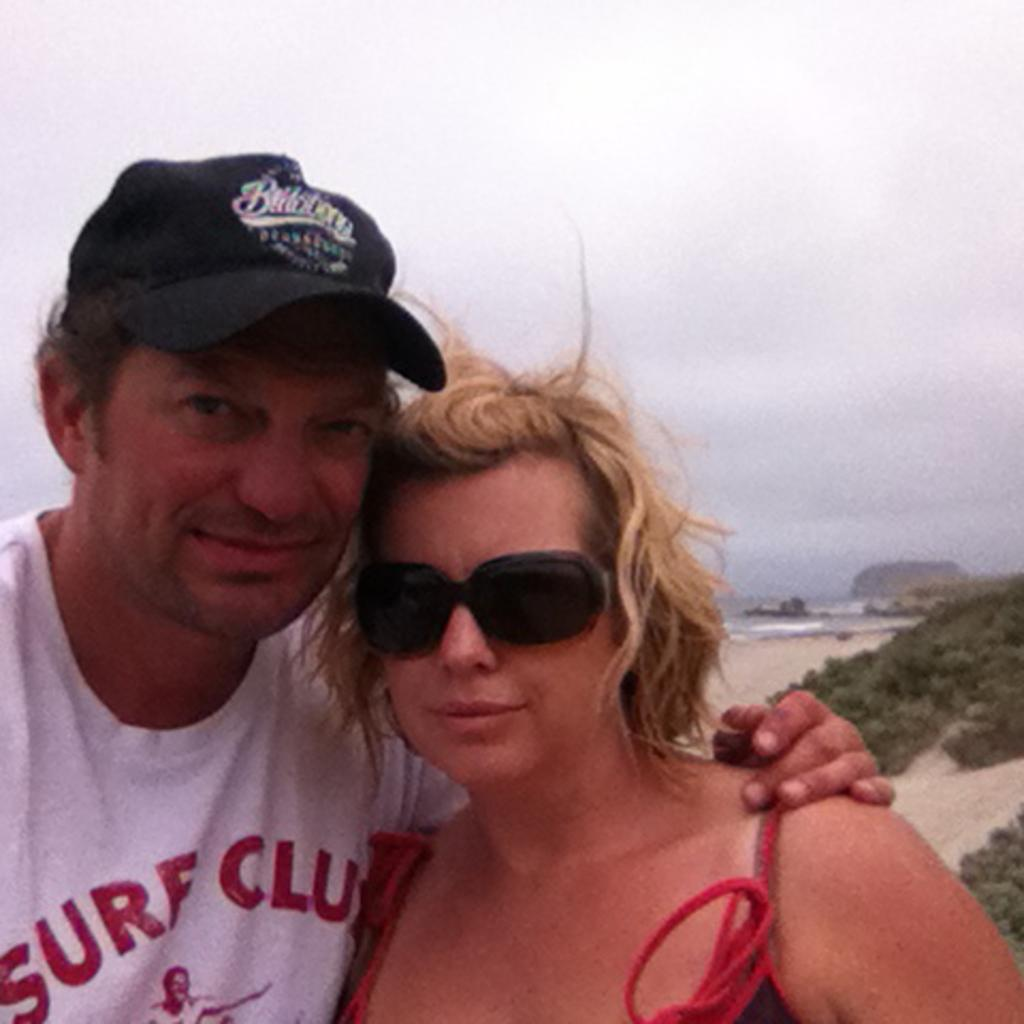Who can be seen in the image? There is a couple standing in the image. What is located behind the couple? There is a river behind the couple. What type of vegetation is visible in the image? There are trees visible in the image. What is visible above the couple and the trees? The sky is visible in the image. What type of oatmeal is being served at the club in the image? There is no oatmeal or club present in the image; it features a couple standing near a river with trees and sky visible. 